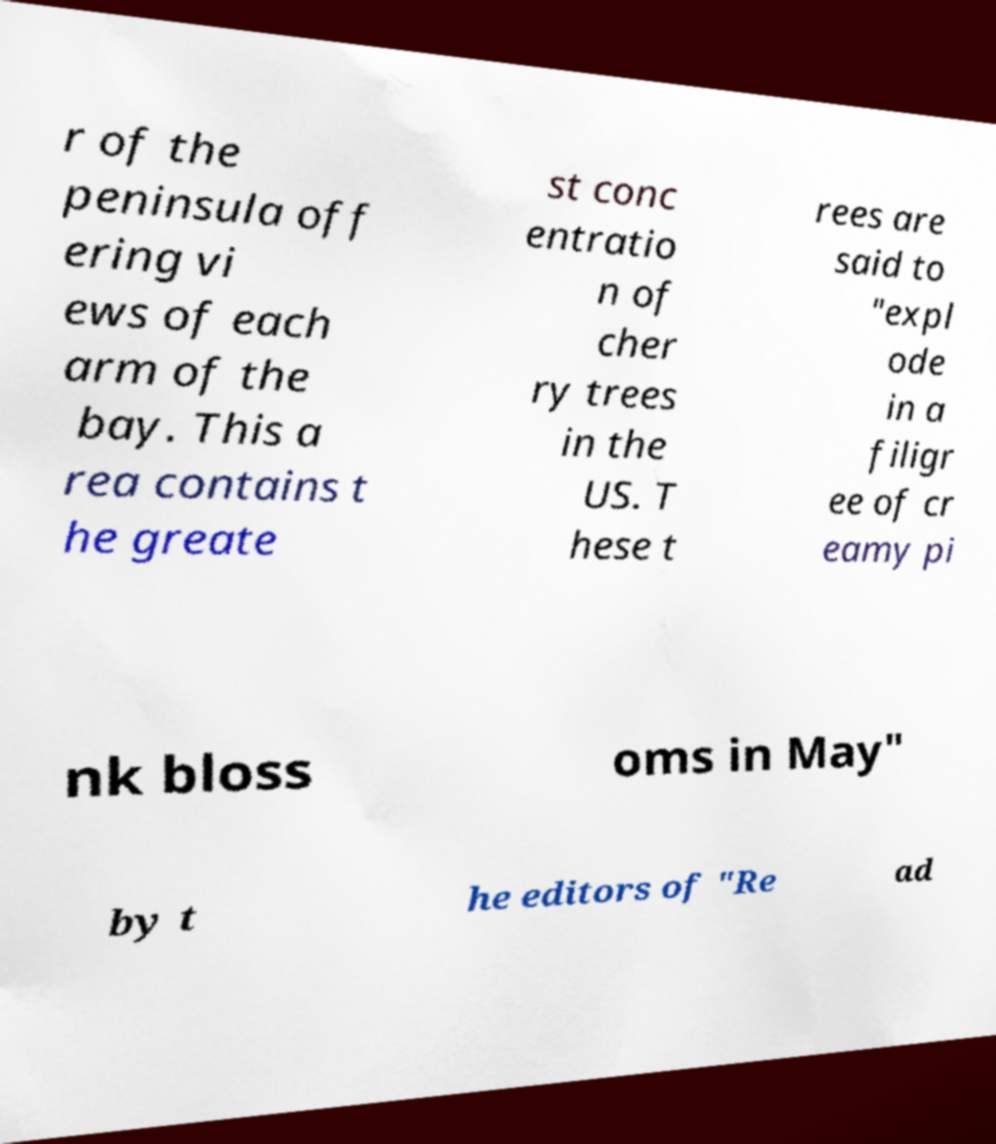There's text embedded in this image that I need extracted. Can you transcribe it verbatim? r of the peninsula off ering vi ews of each arm of the bay. This a rea contains t he greate st conc entratio n of cher ry trees in the US. T hese t rees are said to "expl ode in a filigr ee of cr eamy pi nk bloss oms in May" by t he editors of "Re ad 